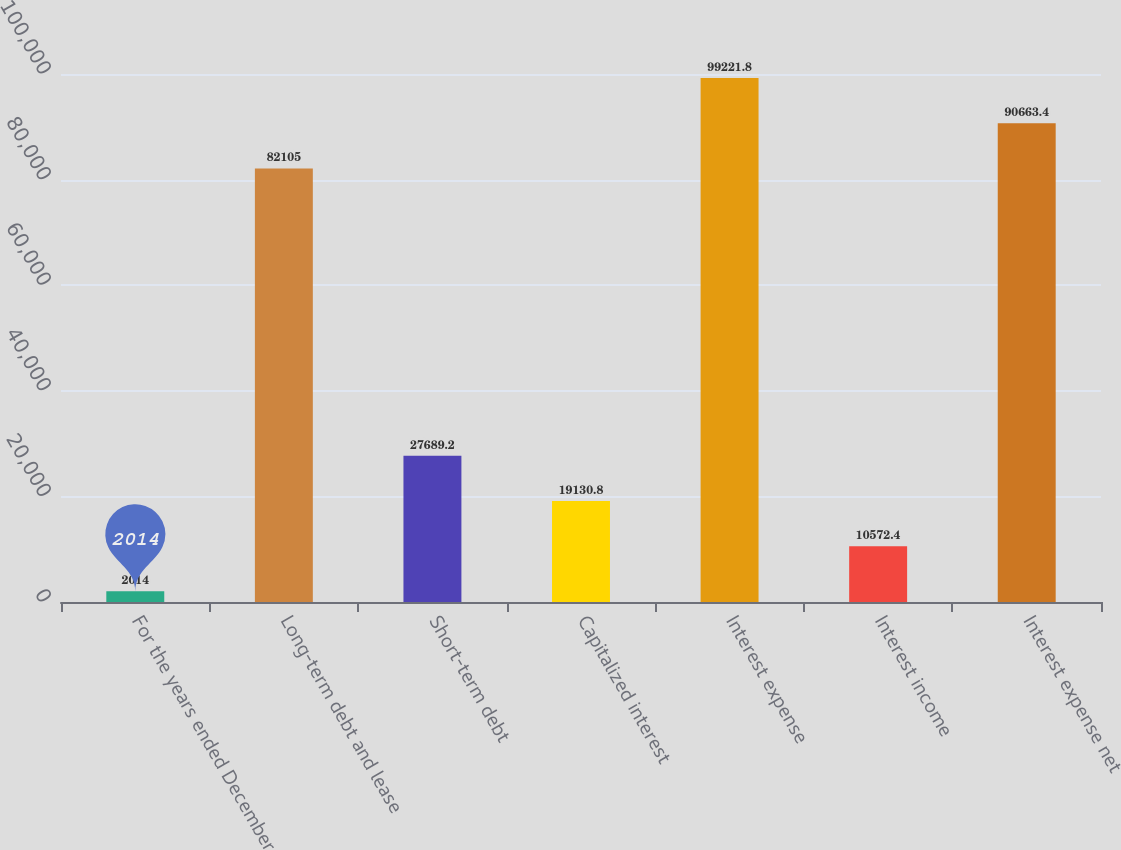Convert chart. <chart><loc_0><loc_0><loc_500><loc_500><bar_chart><fcel>For the years ended December<fcel>Long-term debt and lease<fcel>Short-term debt<fcel>Capitalized interest<fcel>Interest expense<fcel>Interest income<fcel>Interest expense net<nl><fcel>2014<fcel>82105<fcel>27689.2<fcel>19130.8<fcel>99221.8<fcel>10572.4<fcel>90663.4<nl></chart> 